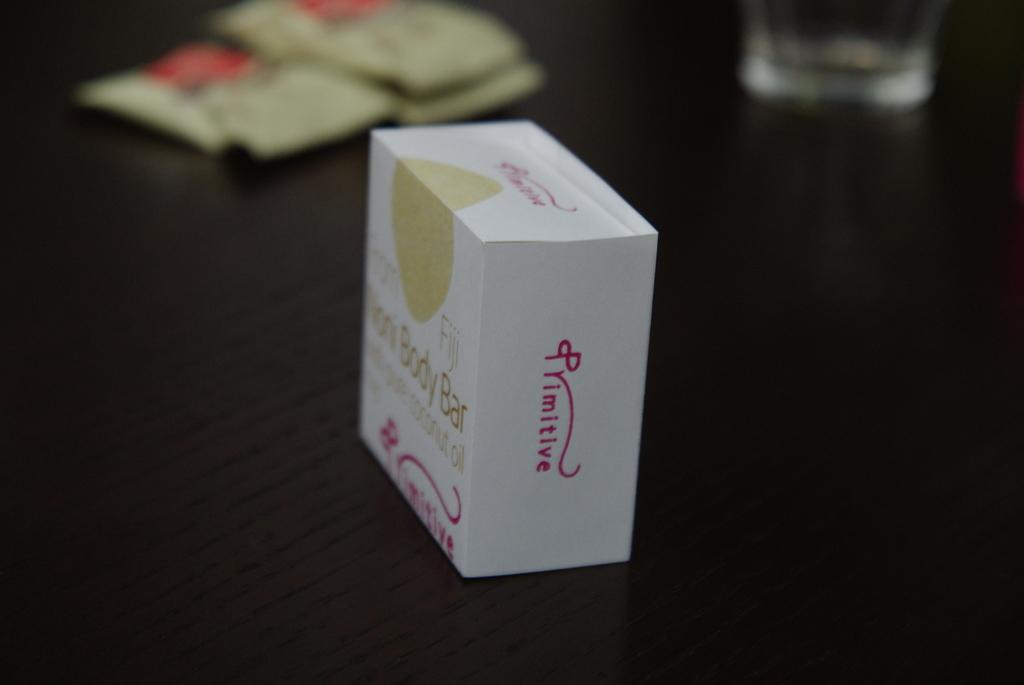<image>
Share a concise interpretation of the image provided. The white box sitting on the table contains a body bar. 